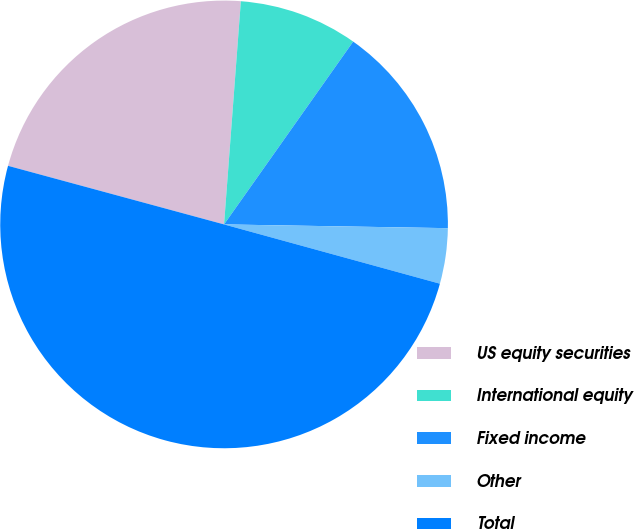<chart> <loc_0><loc_0><loc_500><loc_500><pie_chart><fcel>US equity securities<fcel>International equity<fcel>Fixed income<fcel>Other<fcel>Total<nl><fcel>21.98%<fcel>8.59%<fcel>15.48%<fcel>4.0%<fcel>49.95%<nl></chart> 